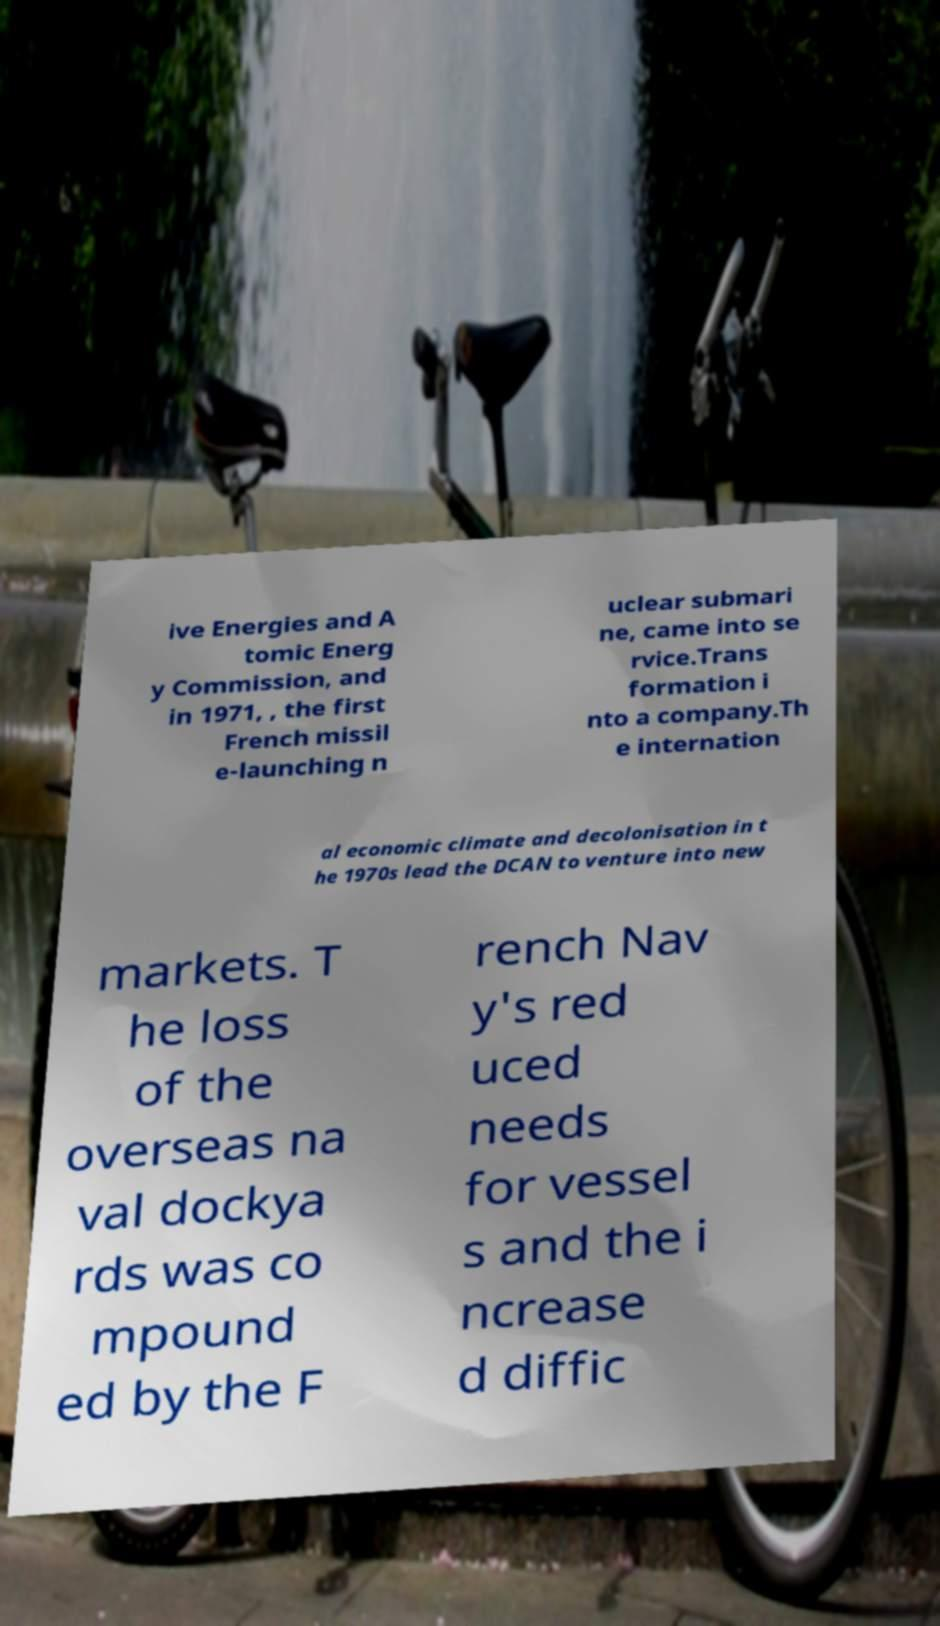Please identify and transcribe the text found in this image. ive Energies and A tomic Energ y Commission, and in 1971, , the first French missil e-launching n uclear submari ne, came into se rvice.Trans formation i nto a company.Th e internation al economic climate and decolonisation in t he 1970s lead the DCAN to venture into new markets. T he loss of the overseas na val dockya rds was co mpound ed by the F rench Nav y's red uced needs for vessel s and the i ncrease d diffic 